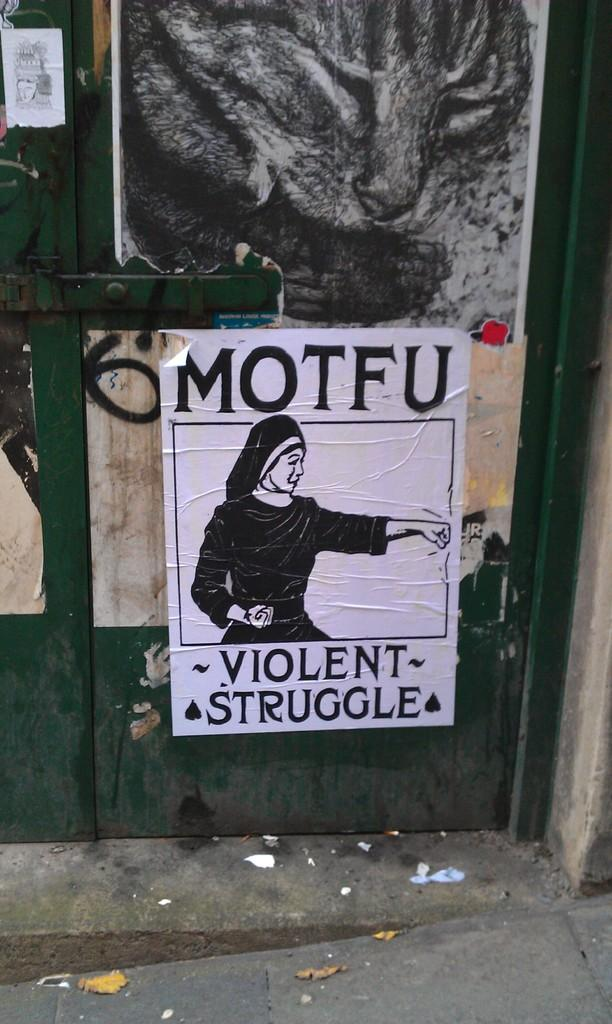What is one of the main features of the image? There is a door in the image. What else can be seen on the walls in the image? There are posters with text and images in the image. What can be seen under the door and posters in the image? The ground is visible in the image. What type of sack is being carried by the mom in the image? There is no mom or sack present in the image. What is the thing that the person in the image is holding? There is no person holding a thing in the image; the only items mentioned are the door, posters, and ground. 